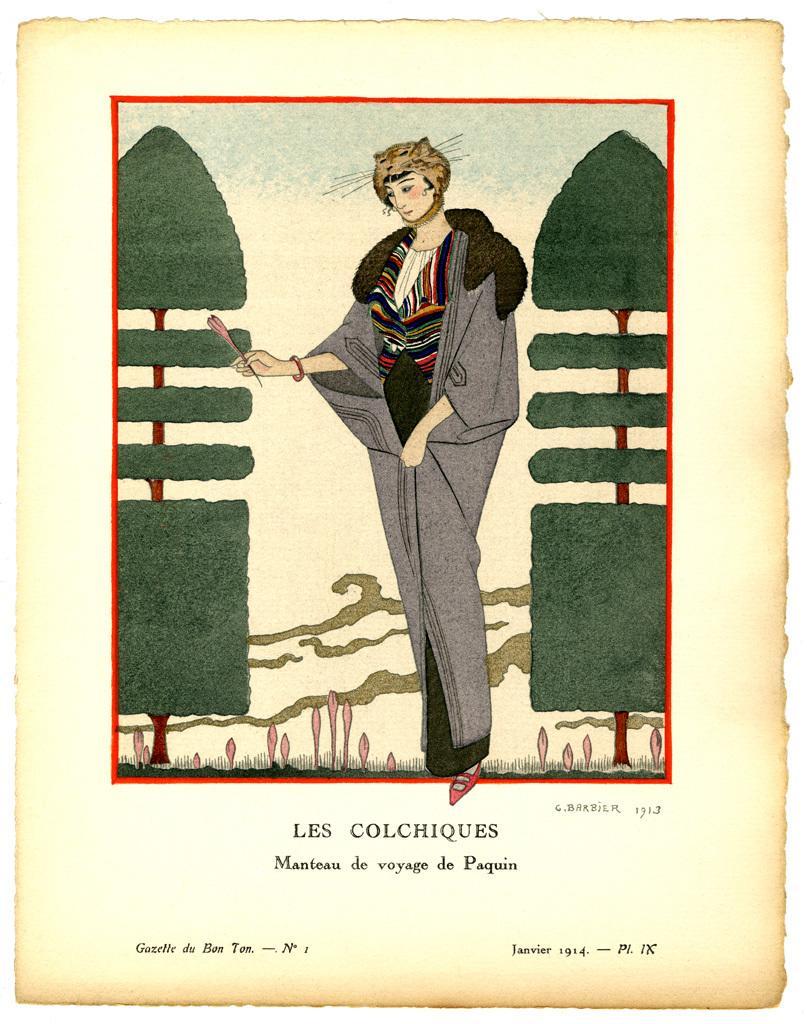How would you summarize this image in a sentence or two? Here we can see poster,in this poster we can see person and trees. 